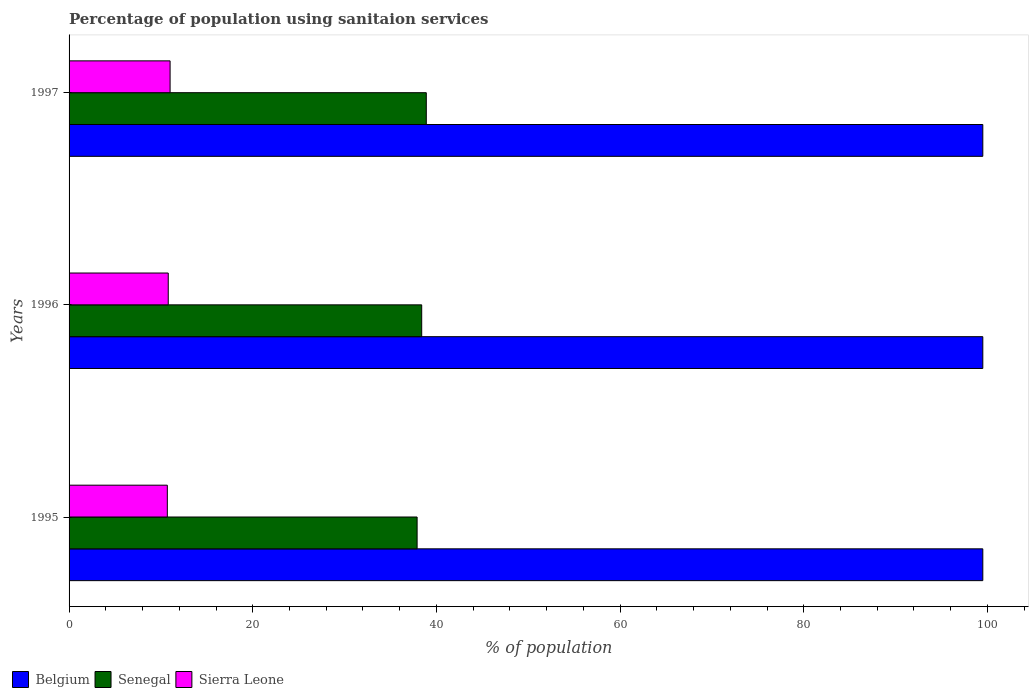How many different coloured bars are there?
Your response must be concise. 3. Are the number of bars per tick equal to the number of legend labels?
Make the answer very short. Yes. Are the number of bars on each tick of the Y-axis equal?
Your answer should be very brief. Yes. In how many cases, is the number of bars for a given year not equal to the number of legend labels?
Ensure brevity in your answer.  0. What is the percentage of population using sanitaion services in Belgium in 1996?
Ensure brevity in your answer.  99.5. Across all years, what is the maximum percentage of population using sanitaion services in Sierra Leone?
Ensure brevity in your answer.  11. Across all years, what is the minimum percentage of population using sanitaion services in Sierra Leone?
Offer a very short reply. 10.7. In which year was the percentage of population using sanitaion services in Belgium maximum?
Give a very brief answer. 1995. In which year was the percentage of population using sanitaion services in Senegal minimum?
Give a very brief answer. 1995. What is the total percentage of population using sanitaion services in Sierra Leone in the graph?
Keep it short and to the point. 32.5. What is the difference between the percentage of population using sanitaion services in Sierra Leone in 1996 and the percentage of population using sanitaion services in Senegal in 1997?
Give a very brief answer. -28.1. What is the average percentage of population using sanitaion services in Senegal per year?
Your answer should be very brief. 38.4. In the year 1996, what is the difference between the percentage of population using sanitaion services in Senegal and percentage of population using sanitaion services in Belgium?
Your answer should be very brief. -61.1. What is the ratio of the percentage of population using sanitaion services in Senegal in 1995 to that in 1996?
Give a very brief answer. 0.99. What is the difference between the highest and the second highest percentage of population using sanitaion services in Sierra Leone?
Your response must be concise. 0.2. What is the difference between the highest and the lowest percentage of population using sanitaion services in Senegal?
Offer a very short reply. 1. What does the 2nd bar from the top in 1997 represents?
Offer a terse response. Senegal. What does the 2nd bar from the bottom in 1997 represents?
Give a very brief answer. Senegal. How many bars are there?
Offer a terse response. 9. How many years are there in the graph?
Provide a short and direct response. 3. What is the difference between two consecutive major ticks on the X-axis?
Make the answer very short. 20. Does the graph contain any zero values?
Provide a succinct answer. No. Does the graph contain grids?
Keep it short and to the point. No. How many legend labels are there?
Offer a very short reply. 3. What is the title of the graph?
Make the answer very short. Percentage of population using sanitaion services. What is the label or title of the X-axis?
Provide a short and direct response. % of population. What is the % of population of Belgium in 1995?
Keep it short and to the point. 99.5. What is the % of population of Senegal in 1995?
Make the answer very short. 37.9. What is the % of population in Sierra Leone in 1995?
Make the answer very short. 10.7. What is the % of population in Belgium in 1996?
Give a very brief answer. 99.5. What is the % of population in Senegal in 1996?
Ensure brevity in your answer.  38.4. What is the % of population in Sierra Leone in 1996?
Provide a succinct answer. 10.8. What is the % of population in Belgium in 1997?
Give a very brief answer. 99.5. What is the % of population of Senegal in 1997?
Make the answer very short. 38.9. Across all years, what is the maximum % of population of Belgium?
Offer a very short reply. 99.5. Across all years, what is the maximum % of population of Senegal?
Keep it short and to the point. 38.9. Across all years, what is the maximum % of population of Sierra Leone?
Make the answer very short. 11. Across all years, what is the minimum % of population in Belgium?
Provide a short and direct response. 99.5. Across all years, what is the minimum % of population of Senegal?
Your answer should be compact. 37.9. Across all years, what is the minimum % of population in Sierra Leone?
Make the answer very short. 10.7. What is the total % of population of Belgium in the graph?
Provide a short and direct response. 298.5. What is the total % of population of Senegal in the graph?
Make the answer very short. 115.2. What is the total % of population of Sierra Leone in the graph?
Provide a short and direct response. 32.5. What is the difference between the % of population of Belgium in 1995 and that in 1996?
Your answer should be very brief. 0. What is the difference between the % of population in Belgium in 1996 and that in 1997?
Provide a succinct answer. 0. What is the difference between the % of population of Sierra Leone in 1996 and that in 1997?
Keep it short and to the point. -0.2. What is the difference between the % of population in Belgium in 1995 and the % of population in Senegal in 1996?
Give a very brief answer. 61.1. What is the difference between the % of population in Belgium in 1995 and the % of population in Sierra Leone in 1996?
Ensure brevity in your answer.  88.7. What is the difference between the % of population in Senegal in 1995 and the % of population in Sierra Leone in 1996?
Make the answer very short. 27.1. What is the difference between the % of population of Belgium in 1995 and the % of population of Senegal in 1997?
Ensure brevity in your answer.  60.6. What is the difference between the % of population in Belgium in 1995 and the % of population in Sierra Leone in 1997?
Your answer should be compact. 88.5. What is the difference between the % of population of Senegal in 1995 and the % of population of Sierra Leone in 1997?
Your answer should be very brief. 26.9. What is the difference between the % of population in Belgium in 1996 and the % of population in Senegal in 1997?
Offer a very short reply. 60.6. What is the difference between the % of population of Belgium in 1996 and the % of population of Sierra Leone in 1997?
Make the answer very short. 88.5. What is the difference between the % of population in Senegal in 1996 and the % of population in Sierra Leone in 1997?
Offer a very short reply. 27.4. What is the average % of population of Belgium per year?
Make the answer very short. 99.5. What is the average % of population of Senegal per year?
Your answer should be compact. 38.4. What is the average % of population of Sierra Leone per year?
Give a very brief answer. 10.83. In the year 1995, what is the difference between the % of population of Belgium and % of population of Senegal?
Your answer should be very brief. 61.6. In the year 1995, what is the difference between the % of population of Belgium and % of population of Sierra Leone?
Ensure brevity in your answer.  88.8. In the year 1995, what is the difference between the % of population of Senegal and % of population of Sierra Leone?
Offer a very short reply. 27.2. In the year 1996, what is the difference between the % of population of Belgium and % of population of Senegal?
Ensure brevity in your answer.  61.1. In the year 1996, what is the difference between the % of population of Belgium and % of population of Sierra Leone?
Offer a terse response. 88.7. In the year 1996, what is the difference between the % of population in Senegal and % of population in Sierra Leone?
Make the answer very short. 27.6. In the year 1997, what is the difference between the % of population of Belgium and % of population of Senegal?
Keep it short and to the point. 60.6. In the year 1997, what is the difference between the % of population of Belgium and % of population of Sierra Leone?
Keep it short and to the point. 88.5. In the year 1997, what is the difference between the % of population of Senegal and % of population of Sierra Leone?
Your answer should be very brief. 27.9. What is the ratio of the % of population in Belgium in 1995 to that in 1996?
Provide a short and direct response. 1. What is the ratio of the % of population of Senegal in 1995 to that in 1997?
Ensure brevity in your answer.  0.97. What is the ratio of the % of population in Sierra Leone in 1995 to that in 1997?
Keep it short and to the point. 0.97. What is the ratio of the % of population in Senegal in 1996 to that in 1997?
Offer a terse response. 0.99. What is the ratio of the % of population of Sierra Leone in 1996 to that in 1997?
Provide a succinct answer. 0.98. What is the difference between the highest and the lowest % of population in Senegal?
Keep it short and to the point. 1. What is the difference between the highest and the lowest % of population in Sierra Leone?
Provide a short and direct response. 0.3. 